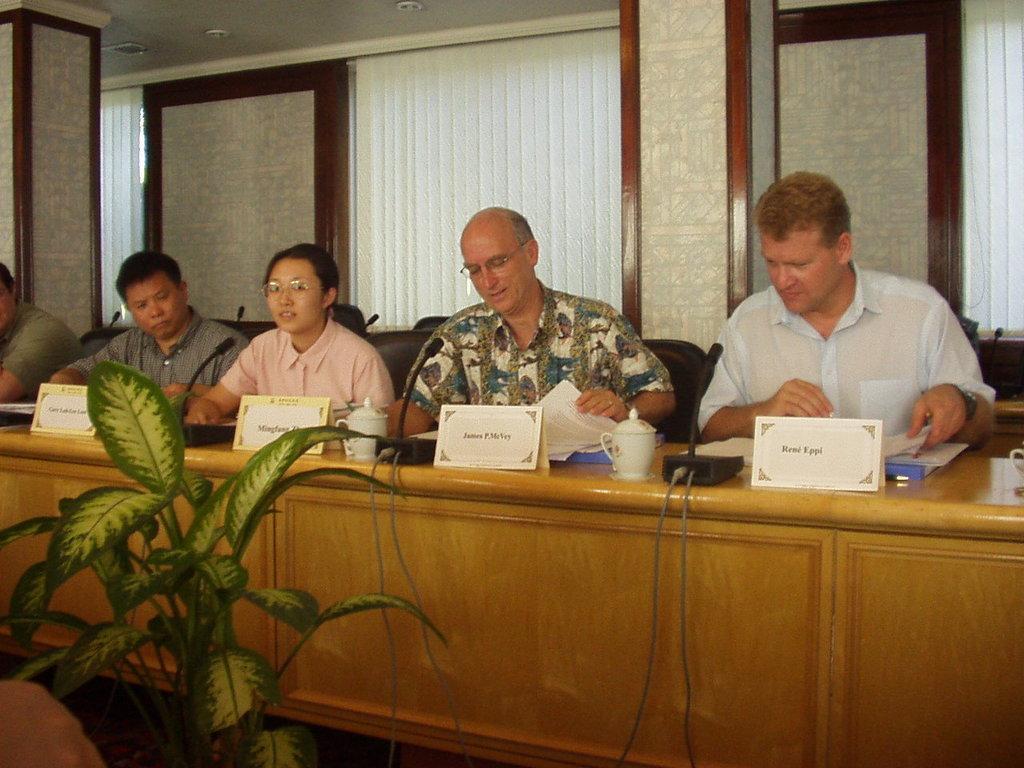How would you summarize this image in a sentence or two? In the center of the image we can see three people sitting, before them there is a table and we can see jars, boards and mics placed on the table. At the bottom there is a plant. In the background there are windows and we can see curtains. 